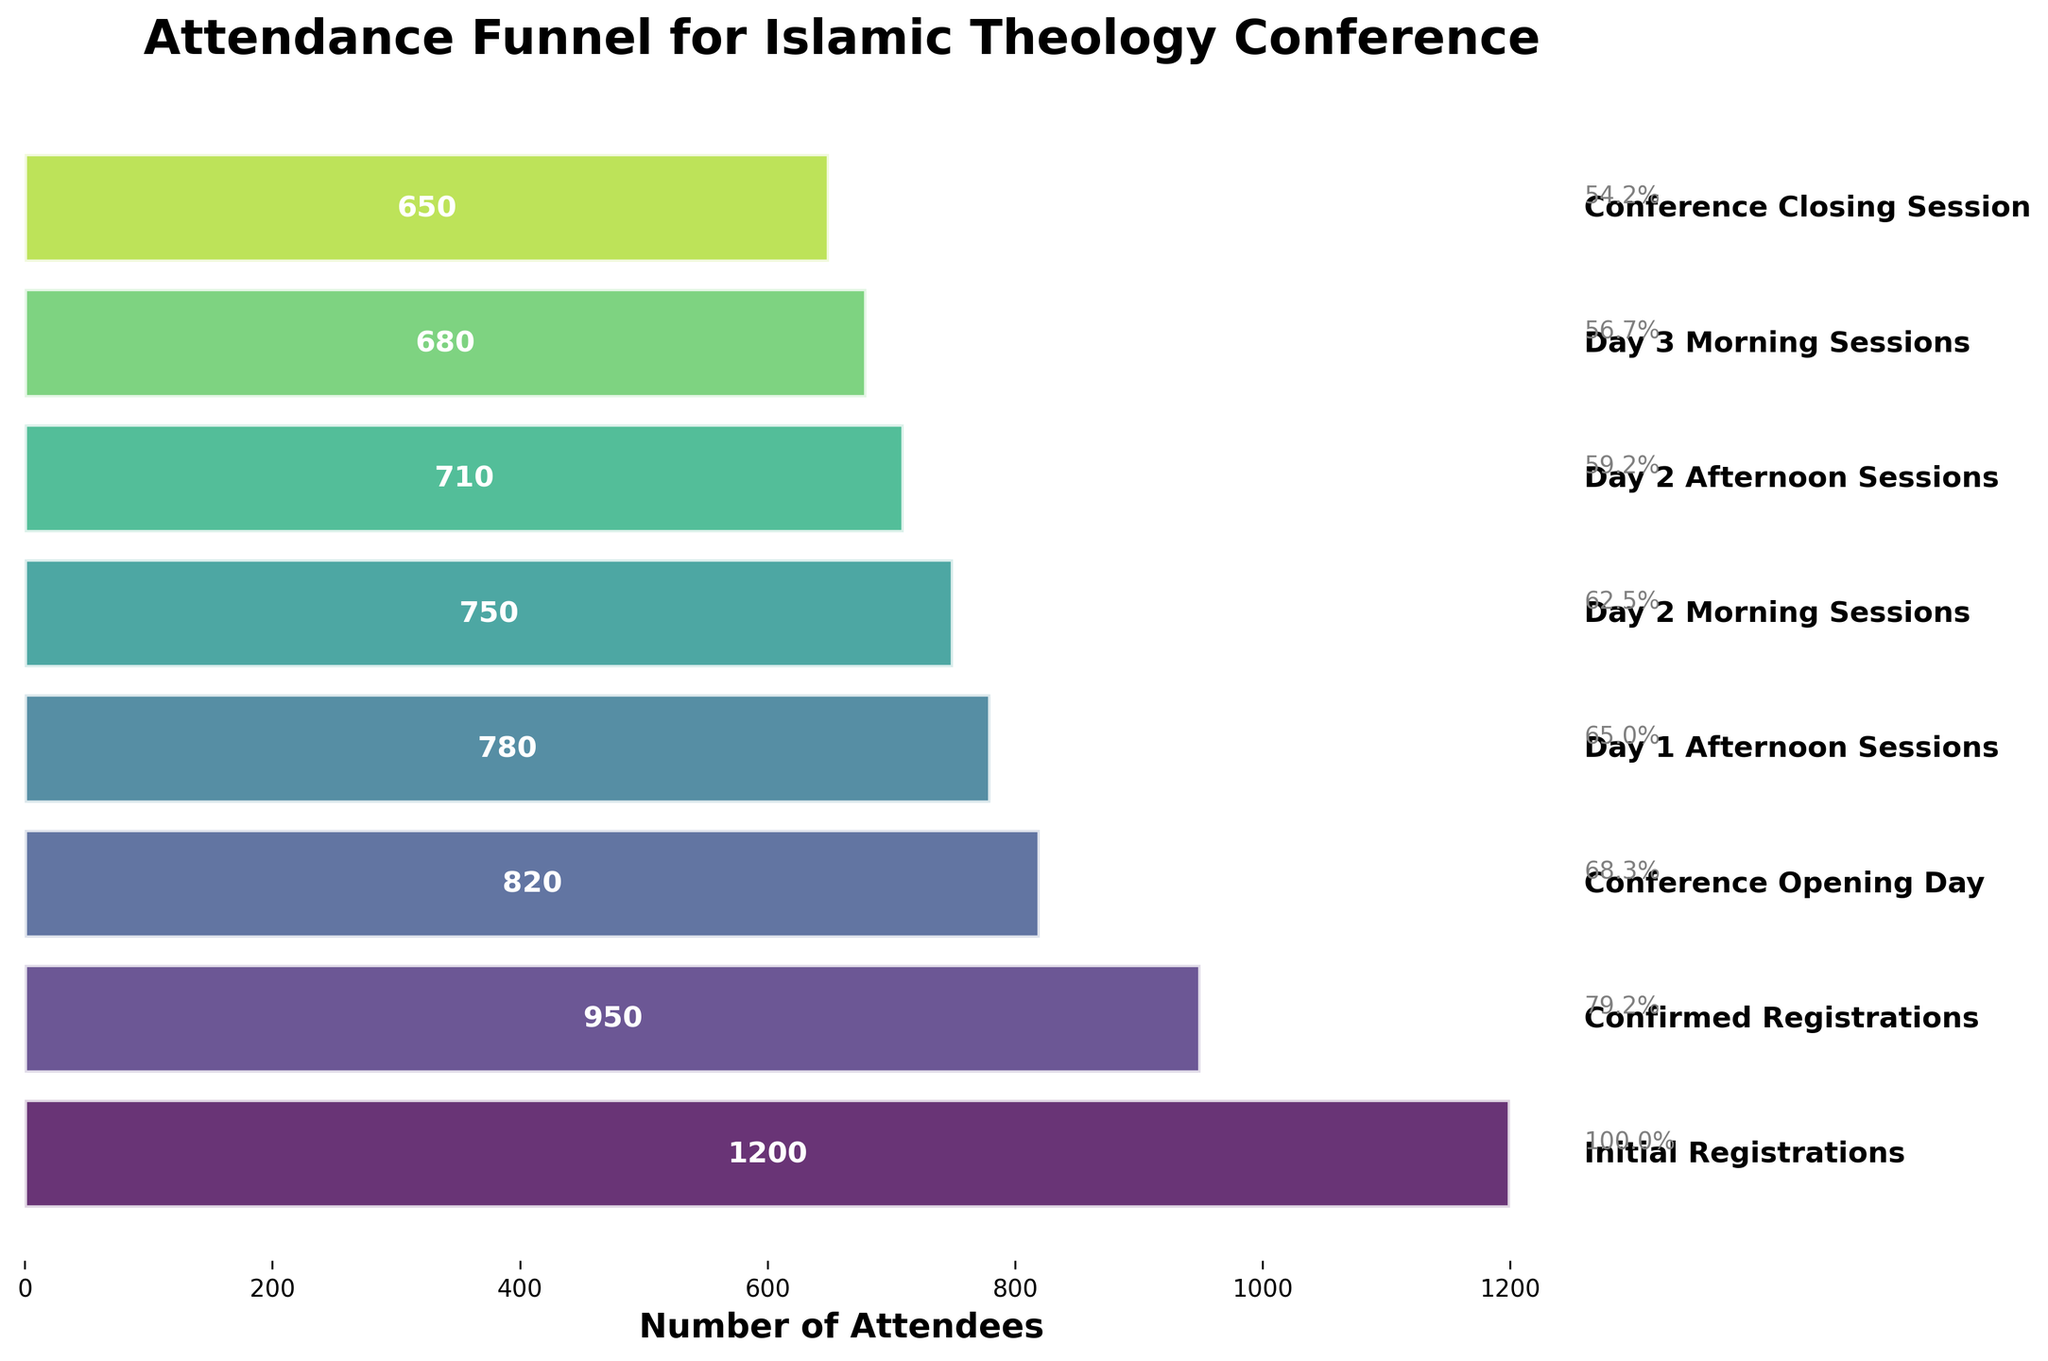What is the title of the figure? The title is written at the top of the figure. It states that the figure is an "Attendance Funnel for Islamic Theology Conference."
Answer: Attendance Funnel for Islamic Theology Conference How many stages are there in the funnel chart? By counting the number of horizontal bars, we can determine that the figure has eight stages.
Answer: Eight What is the number of attendees at the Conference Opening Day? The corresponding horizontal bar for "Conference Opening Day" shows an attendee count of 820, clearly indicated by the label on the bar.
Answer: 820 What is the difference in attendance between the Initial Registrations and the Conference Closing Session? To find this difference, we subtract the number of attendees at the Conference Closing Session from those at the Initial Registrations: 1200 - 650 = 550.
Answer: 550 Which stage has the highest drop in attendance compared to the previous stage? We examine the difference in attendance between consecutive stages and see that the largest drop is from Initial Registrations (1200) to Confirmed Registrations (950), which is a drop of 250 attendees.
Answer: From Initial Registrations to Confirmed Registrations What percentage of initial registrants attended the Conference Closing Session? We calculate the percentage by dividing the attendees at the Conference Closing Session by the Initial Registrations and then multiplying by 100: (650 / 1200) * 100 = 54.17%.
Answer: 54.17% Which sessions have an attendance count lower than 800 attendees? The horizontal bars labeled "Day 2 Afternoon Sessions" (710 attendees), "Day 3 Morning Sessions" (680 attendees), and "Conference Closing Session" (650 attendees) show attendance below 800.
Answer: Day 2 Afternoon Sessions, Day 3 Morning Sessions, Conference Closing Session Is there any stage where more attendees joined than in the preceding stage? We observe the attendance counts for all consecutive stages and notice that none of the stages have an increase in attendees compared to the previous one.
Answer: No How much did attendance decrease from Day 2 Morning Sessions to Day 3 Morning Sessions? The attendance at Day 2 Morning Sessions was 750 and at Day 3 Morning Sessions was 680. The decrease in attendance is calculated as 750 - 680 = 70.
Answer: 70 What is the average number of attendees across all stages? Adding up the attendees for all stages: 1200 + 950 + 820 + 780 + 750 + 710 + 680 + 650 = 6540. The average is then calculated as 6540 / 8 = 817.5.
Answer: 817.5 